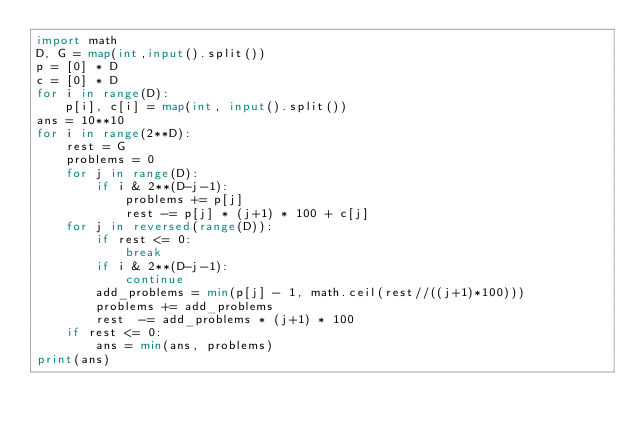<code> <loc_0><loc_0><loc_500><loc_500><_Python_>import math
D, G = map(int,input().split())
p = [0] * D
c = [0] * D
for i in range(D):
    p[i], c[i] = map(int, input().split())
ans = 10**10
for i in range(2**D):
    rest = G
    problems = 0
    for j in range(D):
        if i & 2**(D-j-1):
            problems += p[j]
            rest -= p[j] * (j+1) * 100 + c[j]
    for j in reversed(range(D)):
        if rest <= 0:
            break
        if i & 2**(D-j-1):
            continue
        add_problems = min(p[j] - 1, math.ceil(rest//((j+1)*100)))
        problems += add_problems
        rest  -= add_problems * (j+1) * 100
    if rest <= 0:
        ans = min(ans, problems)
print(ans)</code> 